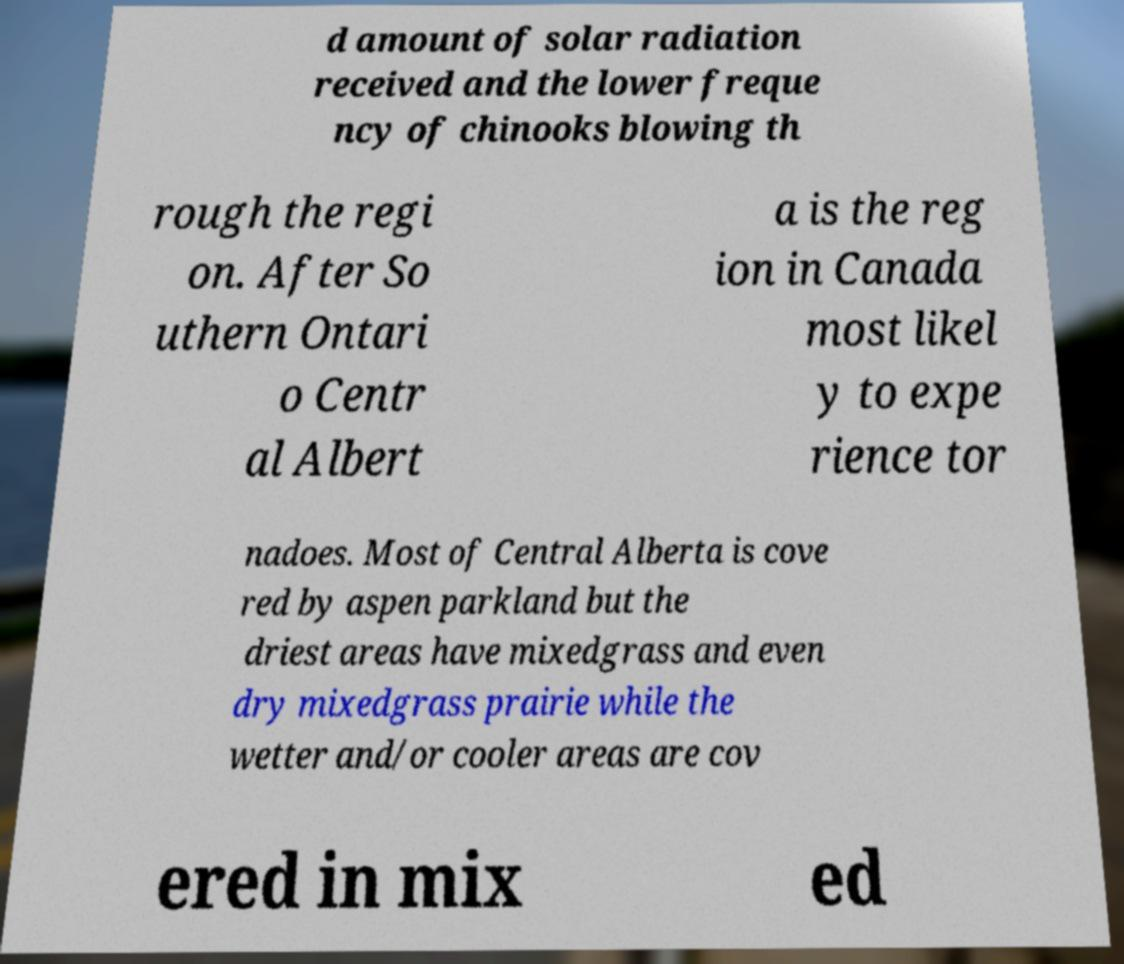Please read and relay the text visible in this image. What does it say? d amount of solar radiation received and the lower freque ncy of chinooks blowing th rough the regi on. After So uthern Ontari o Centr al Albert a is the reg ion in Canada most likel y to expe rience tor nadoes. Most of Central Alberta is cove red by aspen parkland but the driest areas have mixedgrass and even dry mixedgrass prairie while the wetter and/or cooler areas are cov ered in mix ed 